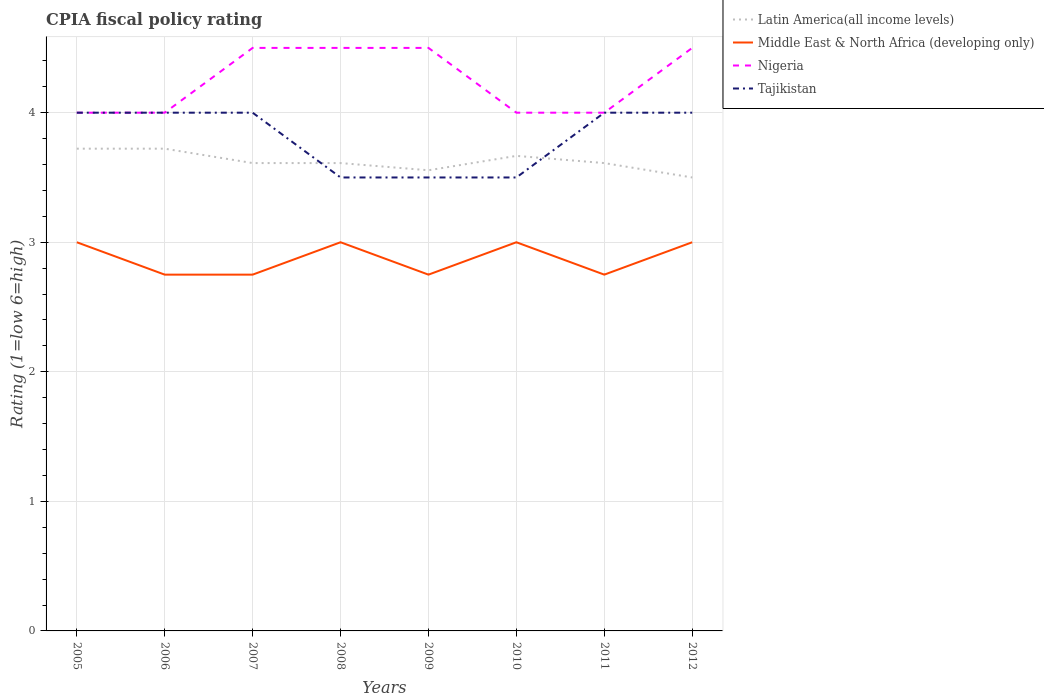Is the number of lines equal to the number of legend labels?
Offer a very short reply. Yes. Across all years, what is the maximum CPIA rating in Nigeria?
Your answer should be compact. 4. What is the difference between the highest and the lowest CPIA rating in Nigeria?
Provide a short and direct response. 4. How many lines are there?
Ensure brevity in your answer.  4. How many years are there in the graph?
Offer a very short reply. 8. What is the difference between two consecutive major ticks on the Y-axis?
Make the answer very short. 1. Are the values on the major ticks of Y-axis written in scientific E-notation?
Your answer should be compact. No. Does the graph contain grids?
Provide a succinct answer. Yes. Where does the legend appear in the graph?
Offer a terse response. Top right. How are the legend labels stacked?
Your answer should be very brief. Vertical. What is the title of the graph?
Give a very brief answer. CPIA fiscal policy rating. What is the label or title of the Y-axis?
Give a very brief answer. Rating (1=low 6=high). What is the Rating (1=low 6=high) in Latin America(all income levels) in 2005?
Your answer should be very brief. 3.72. What is the Rating (1=low 6=high) of Tajikistan in 2005?
Your response must be concise. 4. What is the Rating (1=low 6=high) in Latin America(all income levels) in 2006?
Ensure brevity in your answer.  3.72. What is the Rating (1=low 6=high) in Middle East & North Africa (developing only) in 2006?
Ensure brevity in your answer.  2.75. What is the Rating (1=low 6=high) of Latin America(all income levels) in 2007?
Give a very brief answer. 3.61. What is the Rating (1=low 6=high) in Middle East & North Africa (developing only) in 2007?
Your answer should be compact. 2.75. What is the Rating (1=low 6=high) of Tajikistan in 2007?
Ensure brevity in your answer.  4. What is the Rating (1=low 6=high) in Latin America(all income levels) in 2008?
Offer a terse response. 3.61. What is the Rating (1=low 6=high) in Middle East & North Africa (developing only) in 2008?
Make the answer very short. 3. What is the Rating (1=low 6=high) of Nigeria in 2008?
Ensure brevity in your answer.  4.5. What is the Rating (1=low 6=high) of Latin America(all income levels) in 2009?
Make the answer very short. 3.56. What is the Rating (1=low 6=high) of Middle East & North Africa (developing only) in 2009?
Give a very brief answer. 2.75. What is the Rating (1=low 6=high) in Nigeria in 2009?
Your answer should be very brief. 4.5. What is the Rating (1=low 6=high) in Tajikistan in 2009?
Offer a terse response. 3.5. What is the Rating (1=low 6=high) in Latin America(all income levels) in 2010?
Provide a short and direct response. 3.67. What is the Rating (1=low 6=high) of Tajikistan in 2010?
Offer a terse response. 3.5. What is the Rating (1=low 6=high) in Latin America(all income levels) in 2011?
Your response must be concise. 3.61. What is the Rating (1=low 6=high) of Middle East & North Africa (developing only) in 2011?
Give a very brief answer. 2.75. What is the Rating (1=low 6=high) of Nigeria in 2011?
Provide a succinct answer. 4. What is the Rating (1=low 6=high) of Latin America(all income levels) in 2012?
Give a very brief answer. 3.5. What is the Rating (1=low 6=high) of Nigeria in 2012?
Your answer should be compact. 4.5. Across all years, what is the maximum Rating (1=low 6=high) in Latin America(all income levels)?
Provide a succinct answer. 3.72. Across all years, what is the maximum Rating (1=low 6=high) of Middle East & North Africa (developing only)?
Ensure brevity in your answer.  3. Across all years, what is the maximum Rating (1=low 6=high) of Nigeria?
Your answer should be very brief. 4.5. Across all years, what is the minimum Rating (1=low 6=high) in Middle East & North Africa (developing only)?
Offer a terse response. 2.75. Across all years, what is the minimum Rating (1=low 6=high) in Nigeria?
Offer a very short reply. 4. Across all years, what is the minimum Rating (1=low 6=high) in Tajikistan?
Offer a very short reply. 3.5. What is the total Rating (1=low 6=high) in Middle East & North Africa (developing only) in the graph?
Provide a short and direct response. 23. What is the total Rating (1=low 6=high) in Tajikistan in the graph?
Ensure brevity in your answer.  30.5. What is the difference between the Rating (1=low 6=high) of Middle East & North Africa (developing only) in 2005 and that in 2006?
Your answer should be very brief. 0.25. What is the difference between the Rating (1=low 6=high) in Nigeria in 2005 and that in 2006?
Offer a terse response. 0. What is the difference between the Rating (1=low 6=high) of Middle East & North Africa (developing only) in 2005 and that in 2007?
Offer a terse response. 0.25. What is the difference between the Rating (1=low 6=high) in Nigeria in 2005 and that in 2007?
Your response must be concise. -0.5. What is the difference between the Rating (1=low 6=high) of Latin America(all income levels) in 2005 and that in 2008?
Give a very brief answer. 0.11. What is the difference between the Rating (1=low 6=high) of Middle East & North Africa (developing only) in 2005 and that in 2008?
Provide a short and direct response. 0. What is the difference between the Rating (1=low 6=high) in Nigeria in 2005 and that in 2008?
Ensure brevity in your answer.  -0.5. What is the difference between the Rating (1=low 6=high) in Middle East & North Africa (developing only) in 2005 and that in 2009?
Keep it short and to the point. 0.25. What is the difference between the Rating (1=low 6=high) in Nigeria in 2005 and that in 2009?
Your response must be concise. -0.5. What is the difference between the Rating (1=low 6=high) in Latin America(all income levels) in 2005 and that in 2010?
Offer a very short reply. 0.06. What is the difference between the Rating (1=low 6=high) of Middle East & North Africa (developing only) in 2005 and that in 2010?
Your answer should be compact. 0. What is the difference between the Rating (1=low 6=high) in Tajikistan in 2005 and that in 2010?
Ensure brevity in your answer.  0.5. What is the difference between the Rating (1=low 6=high) in Middle East & North Africa (developing only) in 2005 and that in 2011?
Keep it short and to the point. 0.25. What is the difference between the Rating (1=low 6=high) in Nigeria in 2005 and that in 2011?
Provide a succinct answer. 0. What is the difference between the Rating (1=low 6=high) in Latin America(all income levels) in 2005 and that in 2012?
Offer a terse response. 0.22. What is the difference between the Rating (1=low 6=high) in Middle East & North Africa (developing only) in 2005 and that in 2012?
Give a very brief answer. 0. What is the difference between the Rating (1=low 6=high) in Tajikistan in 2005 and that in 2012?
Offer a very short reply. 0. What is the difference between the Rating (1=low 6=high) of Middle East & North Africa (developing only) in 2006 and that in 2007?
Offer a very short reply. 0. What is the difference between the Rating (1=low 6=high) in Nigeria in 2006 and that in 2007?
Ensure brevity in your answer.  -0.5. What is the difference between the Rating (1=low 6=high) in Latin America(all income levels) in 2006 and that in 2008?
Your answer should be very brief. 0.11. What is the difference between the Rating (1=low 6=high) in Latin America(all income levels) in 2006 and that in 2010?
Your response must be concise. 0.06. What is the difference between the Rating (1=low 6=high) in Tajikistan in 2006 and that in 2010?
Your answer should be compact. 0.5. What is the difference between the Rating (1=low 6=high) in Middle East & North Africa (developing only) in 2006 and that in 2011?
Provide a succinct answer. 0. What is the difference between the Rating (1=low 6=high) of Nigeria in 2006 and that in 2011?
Make the answer very short. 0. What is the difference between the Rating (1=low 6=high) of Latin America(all income levels) in 2006 and that in 2012?
Your response must be concise. 0.22. What is the difference between the Rating (1=low 6=high) of Nigeria in 2006 and that in 2012?
Your answer should be compact. -0.5. What is the difference between the Rating (1=low 6=high) of Middle East & North Africa (developing only) in 2007 and that in 2008?
Ensure brevity in your answer.  -0.25. What is the difference between the Rating (1=low 6=high) in Tajikistan in 2007 and that in 2008?
Your answer should be compact. 0.5. What is the difference between the Rating (1=low 6=high) of Latin America(all income levels) in 2007 and that in 2009?
Your response must be concise. 0.06. What is the difference between the Rating (1=low 6=high) in Middle East & North Africa (developing only) in 2007 and that in 2009?
Your answer should be compact. 0. What is the difference between the Rating (1=low 6=high) of Tajikistan in 2007 and that in 2009?
Your response must be concise. 0.5. What is the difference between the Rating (1=low 6=high) in Latin America(all income levels) in 2007 and that in 2010?
Offer a terse response. -0.06. What is the difference between the Rating (1=low 6=high) of Tajikistan in 2007 and that in 2010?
Make the answer very short. 0.5. What is the difference between the Rating (1=low 6=high) of Latin America(all income levels) in 2007 and that in 2011?
Ensure brevity in your answer.  0. What is the difference between the Rating (1=low 6=high) of Middle East & North Africa (developing only) in 2007 and that in 2011?
Your answer should be very brief. 0. What is the difference between the Rating (1=low 6=high) of Nigeria in 2007 and that in 2011?
Provide a succinct answer. 0.5. What is the difference between the Rating (1=low 6=high) in Tajikistan in 2007 and that in 2011?
Give a very brief answer. 0. What is the difference between the Rating (1=low 6=high) in Latin America(all income levels) in 2007 and that in 2012?
Ensure brevity in your answer.  0.11. What is the difference between the Rating (1=low 6=high) of Middle East & North Africa (developing only) in 2007 and that in 2012?
Make the answer very short. -0.25. What is the difference between the Rating (1=low 6=high) in Latin America(all income levels) in 2008 and that in 2009?
Make the answer very short. 0.06. What is the difference between the Rating (1=low 6=high) of Latin America(all income levels) in 2008 and that in 2010?
Your response must be concise. -0.06. What is the difference between the Rating (1=low 6=high) of Middle East & North Africa (developing only) in 2008 and that in 2010?
Keep it short and to the point. 0. What is the difference between the Rating (1=low 6=high) in Tajikistan in 2008 and that in 2010?
Keep it short and to the point. 0. What is the difference between the Rating (1=low 6=high) of Latin America(all income levels) in 2008 and that in 2011?
Your answer should be compact. 0. What is the difference between the Rating (1=low 6=high) in Latin America(all income levels) in 2008 and that in 2012?
Your response must be concise. 0.11. What is the difference between the Rating (1=low 6=high) in Nigeria in 2008 and that in 2012?
Offer a very short reply. 0. What is the difference between the Rating (1=low 6=high) of Latin America(all income levels) in 2009 and that in 2010?
Your response must be concise. -0.11. What is the difference between the Rating (1=low 6=high) of Nigeria in 2009 and that in 2010?
Offer a terse response. 0.5. What is the difference between the Rating (1=low 6=high) of Tajikistan in 2009 and that in 2010?
Your answer should be compact. 0. What is the difference between the Rating (1=low 6=high) of Latin America(all income levels) in 2009 and that in 2011?
Your answer should be very brief. -0.06. What is the difference between the Rating (1=low 6=high) of Middle East & North Africa (developing only) in 2009 and that in 2011?
Make the answer very short. 0. What is the difference between the Rating (1=low 6=high) of Tajikistan in 2009 and that in 2011?
Ensure brevity in your answer.  -0.5. What is the difference between the Rating (1=low 6=high) of Latin America(all income levels) in 2009 and that in 2012?
Keep it short and to the point. 0.06. What is the difference between the Rating (1=low 6=high) of Middle East & North Africa (developing only) in 2009 and that in 2012?
Your answer should be very brief. -0.25. What is the difference between the Rating (1=low 6=high) of Latin America(all income levels) in 2010 and that in 2011?
Make the answer very short. 0.06. What is the difference between the Rating (1=low 6=high) of Nigeria in 2010 and that in 2011?
Make the answer very short. 0. What is the difference between the Rating (1=low 6=high) of Tajikistan in 2010 and that in 2011?
Give a very brief answer. -0.5. What is the difference between the Rating (1=low 6=high) in Middle East & North Africa (developing only) in 2011 and that in 2012?
Provide a short and direct response. -0.25. What is the difference between the Rating (1=low 6=high) of Tajikistan in 2011 and that in 2012?
Offer a very short reply. 0. What is the difference between the Rating (1=low 6=high) of Latin America(all income levels) in 2005 and the Rating (1=low 6=high) of Middle East & North Africa (developing only) in 2006?
Make the answer very short. 0.97. What is the difference between the Rating (1=low 6=high) of Latin America(all income levels) in 2005 and the Rating (1=low 6=high) of Nigeria in 2006?
Keep it short and to the point. -0.28. What is the difference between the Rating (1=low 6=high) of Latin America(all income levels) in 2005 and the Rating (1=low 6=high) of Tajikistan in 2006?
Your response must be concise. -0.28. What is the difference between the Rating (1=low 6=high) of Middle East & North Africa (developing only) in 2005 and the Rating (1=low 6=high) of Nigeria in 2006?
Give a very brief answer. -1. What is the difference between the Rating (1=low 6=high) of Latin America(all income levels) in 2005 and the Rating (1=low 6=high) of Middle East & North Africa (developing only) in 2007?
Offer a very short reply. 0.97. What is the difference between the Rating (1=low 6=high) in Latin America(all income levels) in 2005 and the Rating (1=low 6=high) in Nigeria in 2007?
Your answer should be compact. -0.78. What is the difference between the Rating (1=low 6=high) of Latin America(all income levels) in 2005 and the Rating (1=low 6=high) of Tajikistan in 2007?
Your response must be concise. -0.28. What is the difference between the Rating (1=low 6=high) of Middle East & North Africa (developing only) in 2005 and the Rating (1=low 6=high) of Nigeria in 2007?
Offer a terse response. -1.5. What is the difference between the Rating (1=low 6=high) in Nigeria in 2005 and the Rating (1=low 6=high) in Tajikistan in 2007?
Offer a terse response. 0. What is the difference between the Rating (1=low 6=high) of Latin America(all income levels) in 2005 and the Rating (1=low 6=high) of Middle East & North Africa (developing only) in 2008?
Make the answer very short. 0.72. What is the difference between the Rating (1=low 6=high) in Latin America(all income levels) in 2005 and the Rating (1=low 6=high) in Nigeria in 2008?
Provide a succinct answer. -0.78. What is the difference between the Rating (1=low 6=high) of Latin America(all income levels) in 2005 and the Rating (1=low 6=high) of Tajikistan in 2008?
Provide a short and direct response. 0.22. What is the difference between the Rating (1=low 6=high) in Middle East & North Africa (developing only) in 2005 and the Rating (1=low 6=high) in Nigeria in 2008?
Your answer should be very brief. -1.5. What is the difference between the Rating (1=low 6=high) in Nigeria in 2005 and the Rating (1=low 6=high) in Tajikistan in 2008?
Your answer should be very brief. 0.5. What is the difference between the Rating (1=low 6=high) of Latin America(all income levels) in 2005 and the Rating (1=low 6=high) of Middle East & North Africa (developing only) in 2009?
Give a very brief answer. 0.97. What is the difference between the Rating (1=low 6=high) of Latin America(all income levels) in 2005 and the Rating (1=low 6=high) of Nigeria in 2009?
Keep it short and to the point. -0.78. What is the difference between the Rating (1=low 6=high) in Latin America(all income levels) in 2005 and the Rating (1=low 6=high) in Tajikistan in 2009?
Your response must be concise. 0.22. What is the difference between the Rating (1=low 6=high) of Middle East & North Africa (developing only) in 2005 and the Rating (1=low 6=high) of Nigeria in 2009?
Give a very brief answer. -1.5. What is the difference between the Rating (1=low 6=high) in Nigeria in 2005 and the Rating (1=low 6=high) in Tajikistan in 2009?
Ensure brevity in your answer.  0.5. What is the difference between the Rating (1=low 6=high) in Latin America(all income levels) in 2005 and the Rating (1=low 6=high) in Middle East & North Africa (developing only) in 2010?
Give a very brief answer. 0.72. What is the difference between the Rating (1=low 6=high) of Latin America(all income levels) in 2005 and the Rating (1=low 6=high) of Nigeria in 2010?
Keep it short and to the point. -0.28. What is the difference between the Rating (1=low 6=high) in Latin America(all income levels) in 2005 and the Rating (1=low 6=high) in Tajikistan in 2010?
Provide a short and direct response. 0.22. What is the difference between the Rating (1=low 6=high) in Nigeria in 2005 and the Rating (1=low 6=high) in Tajikistan in 2010?
Make the answer very short. 0.5. What is the difference between the Rating (1=low 6=high) in Latin America(all income levels) in 2005 and the Rating (1=low 6=high) in Middle East & North Africa (developing only) in 2011?
Your answer should be very brief. 0.97. What is the difference between the Rating (1=low 6=high) of Latin America(all income levels) in 2005 and the Rating (1=low 6=high) of Nigeria in 2011?
Offer a very short reply. -0.28. What is the difference between the Rating (1=low 6=high) of Latin America(all income levels) in 2005 and the Rating (1=low 6=high) of Tajikistan in 2011?
Make the answer very short. -0.28. What is the difference between the Rating (1=low 6=high) in Middle East & North Africa (developing only) in 2005 and the Rating (1=low 6=high) in Tajikistan in 2011?
Offer a very short reply. -1. What is the difference between the Rating (1=low 6=high) of Latin America(all income levels) in 2005 and the Rating (1=low 6=high) of Middle East & North Africa (developing only) in 2012?
Provide a short and direct response. 0.72. What is the difference between the Rating (1=low 6=high) in Latin America(all income levels) in 2005 and the Rating (1=low 6=high) in Nigeria in 2012?
Provide a succinct answer. -0.78. What is the difference between the Rating (1=low 6=high) in Latin America(all income levels) in 2005 and the Rating (1=low 6=high) in Tajikistan in 2012?
Provide a succinct answer. -0.28. What is the difference between the Rating (1=low 6=high) in Middle East & North Africa (developing only) in 2005 and the Rating (1=low 6=high) in Tajikistan in 2012?
Offer a very short reply. -1. What is the difference between the Rating (1=low 6=high) in Latin America(all income levels) in 2006 and the Rating (1=low 6=high) in Middle East & North Africa (developing only) in 2007?
Provide a short and direct response. 0.97. What is the difference between the Rating (1=low 6=high) in Latin America(all income levels) in 2006 and the Rating (1=low 6=high) in Nigeria in 2007?
Make the answer very short. -0.78. What is the difference between the Rating (1=low 6=high) of Latin America(all income levels) in 2006 and the Rating (1=low 6=high) of Tajikistan in 2007?
Provide a succinct answer. -0.28. What is the difference between the Rating (1=low 6=high) of Middle East & North Africa (developing only) in 2006 and the Rating (1=low 6=high) of Nigeria in 2007?
Make the answer very short. -1.75. What is the difference between the Rating (1=low 6=high) in Middle East & North Africa (developing only) in 2006 and the Rating (1=low 6=high) in Tajikistan in 2007?
Keep it short and to the point. -1.25. What is the difference between the Rating (1=low 6=high) of Nigeria in 2006 and the Rating (1=low 6=high) of Tajikistan in 2007?
Your answer should be very brief. 0. What is the difference between the Rating (1=low 6=high) of Latin America(all income levels) in 2006 and the Rating (1=low 6=high) of Middle East & North Africa (developing only) in 2008?
Keep it short and to the point. 0.72. What is the difference between the Rating (1=low 6=high) of Latin America(all income levels) in 2006 and the Rating (1=low 6=high) of Nigeria in 2008?
Make the answer very short. -0.78. What is the difference between the Rating (1=low 6=high) of Latin America(all income levels) in 2006 and the Rating (1=low 6=high) of Tajikistan in 2008?
Your answer should be very brief. 0.22. What is the difference between the Rating (1=low 6=high) in Middle East & North Africa (developing only) in 2006 and the Rating (1=low 6=high) in Nigeria in 2008?
Provide a short and direct response. -1.75. What is the difference between the Rating (1=low 6=high) in Middle East & North Africa (developing only) in 2006 and the Rating (1=low 6=high) in Tajikistan in 2008?
Provide a short and direct response. -0.75. What is the difference between the Rating (1=low 6=high) of Nigeria in 2006 and the Rating (1=low 6=high) of Tajikistan in 2008?
Ensure brevity in your answer.  0.5. What is the difference between the Rating (1=low 6=high) in Latin America(all income levels) in 2006 and the Rating (1=low 6=high) in Middle East & North Africa (developing only) in 2009?
Provide a succinct answer. 0.97. What is the difference between the Rating (1=low 6=high) in Latin America(all income levels) in 2006 and the Rating (1=low 6=high) in Nigeria in 2009?
Your answer should be compact. -0.78. What is the difference between the Rating (1=low 6=high) of Latin America(all income levels) in 2006 and the Rating (1=low 6=high) of Tajikistan in 2009?
Offer a terse response. 0.22. What is the difference between the Rating (1=low 6=high) in Middle East & North Africa (developing only) in 2006 and the Rating (1=low 6=high) in Nigeria in 2009?
Provide a short and direct response. -1.75. What is the difference between the Rating (1=low 6=high) of Middle East & North Africa (developing only) in 2006 and the Rating (1=low 6=high) of Tajikistan in 2009?
Provide a succinct answer. -0.75. What is the difference between the Rating (1=low 6=high) in Nigeria in 2006 and the Rating (1=low 6=high) in Tajikistan in 2009?
Give a very brief answer. 0.5. What is the difference between the Rating (1=low 6=high) of Latin America(all income levels) in 2006 and the Rating (1=low 6=high) of Middle East & North Africa (developing only) in 2010?
Ensure brevity in your answer.  0.72. What is the difference between the Rating (1=low 6=high) in Latin America(all income levels) in 2006 and the Rating (1=low 6=high) in Nigeria in 2010?
Your answer should be very brief. -0.28. What is the difference between the Rating (1=low 6=high) in Latin America(all income levels) in 2006 and the Rating (1=low 6=high) in Tajikistan in 2010?
Give a very brief answer. 0.22. What is the difference between the Rating (1=low 6=high) of Middle East & North Africa (developing only) in 2006 and the Rating (1=low 6=high) of Nigeria in 2010?
Provide a succinct answer. -1.25. What is the difference between the Rating (1=low 6=high) of Middle East & North Africa (developing only) in 2006 and the Rating (1=low 6=high) of Tajikistan in 2010?
Your answer should be compact. -0.75. What is the difference between the Rating (1=low 6=high) of Latin America(all income levels) in 2006 and the Rating (1=low 6=high) of Middle East & North Africa (developing only) in 2011?
Provide a short and direct response. 0.97. What is the difference between the Rating (1=low 6=high) of Latin America(all income levels) in 2006 and the Rating (1=low 6=high) of Nigeria in 2011?
Ensure brevity in your answer.  -0.28. What is the difference between the Rating (1=low 6=high) in Latin America(all income levels) in 2006 and the Rating (1=low 6=high) in Tajikistan in 2011?
Give a very brief answer. -0.28. What is the difference between the Rating (1=low 6=high) in Middle East & North Africa (developing only) in 2006 and the Rating (1=low 6=high) in Nigeria in 2011?
Provide a succinct answer. -1.25. What is the difference between the Rating (1=low 6=high) of Middle East & North Africa (developing only) in 2006 and the Rating (1=low 6=high) of Tajikistan in 2011?
Ensure brevity in your answer.  -1.25. What is the difference between the Rating (1=low 6=high) in Latin America(all income levels) in 2006 and the Rating (1=low 6=high) in Middle East & North Africa (developing only) in 2012?
Your response must be concise. 0.72. What is the difference between the Rating (1=low 6=high) of Latin America(all income levels) in 2006 and the Rating (1=low 6=high) of Nigeria in 2012?
Offer a terse response. -0.78. What is the difference between the Rating (1=low 6=high) in Latin America(all income levels) in 2006 and the Rating (1=low 6=high) in Tajikistan in 2012?
Provide a short and direct response. -0.28. What is the difference between the Rating (1=low 6=high) in Middle East & North Africa (developing only) in 2006 and the Rating (1=low 6=high) in Nigeria in 2012?
Your answer should be very brief. -1.75. What is the difference between the Rating (1=low 6=high) of Middle East & North Africa (developing only) in 2006 and the Rating (1=low 6=high) of Tajikistan in 2012?
Provide a short and direct response. -1.25. What is the difference between the Rating (1=low 6=high) of Nigeria in 2006 and the Rating (1=low 6=high) of Tajikistan in 2012?
Your answer should be very brief. 0. What is the difference between the Rating (1=low 6=high) of Latin America(all income levels) in 2007 and the Rating (1=low 6=high) of Middle East & North Africa (developing only) in 2008?
Provide a succinct answer. 0.61. What is the difference between the Rating (1=low 6=high) of Latin America(all income levels) in 2007 and the Rating (1=low 6=high) of Nigeria in 2008?
Your response must be concise. -0.89. What is the difference between the Rating (1=low 6=high) of Latin America(all income levels) in 2007 and the Rating (1=low 6=high) of Tajikistan in 2008?
Your answer should be very brief. 0.11. What is the difference between the Rating (1=low 6=high) of Middle East & North Africa (developing only) in 2007 and the Rating (1=low 6=high) of Nigeria in 2008?
Keep it short and to the point. -1.75. What is the difference between the Rating (1=low 6=high) of Middle East & North Africa (developing only) in 2007 and the Rating (1=low 6=high) of Tajikistan in 2008?
Your response must be concise. -0.75. What is the difference between the Rating (1=low 6=high) of Nigeria in 2007 and the Rating (1=low 6=high) of Tajikistan in 2008?
Ensure brevity in your answer.  1. What is the difference between the Rating (1=low 6=high) in Latin America(all income levels) in 2007 and the Rating (1=low 6=high) in Middle East & North Africa (developing only) in 2009?
Offer a very short reply. 0.86. What is the difference between the Rating (1=low 6=high) in Latin America(all income levels) in 2007 and the Rating (1=low 6=high) in Nigeria in 2009?
Provide a short and direct response. -0.89. What is the difference between the Rating (1=low 6=high) of Latin America(all income levels) in 2007 and the Rating (1=low 6=high) of Tajikistan in 2009?
Give a very brief answer. 0.11. What is the difference between the Rating (1=low 6=high) of Middle East & North Africa (developing only) in 2007 and the Rating (1=low 6=high) of Nigeria in 2009?
Your response must be concise. -1.75. What is the difference between the Rating (1=low 6=high) of Middle East & North Africa (developing only) in 2007 and the Rating (1=low 6=high) of Tajikistan in 2009?
Provide a succinct answer. -0.75. What is the difference between the Rating (1=low 6=high) of Latin America(all income levels) in 2007 and the Rating (1=low 6=high) of Middle East & North Africa (developing only) in 2010?
Your answer should be compact. 0.61. What is the difference between the Rating (1=low 6=high) in Latin America(all income levels) in 2007 and the Rating (1=low 6=high) in Nigeria in 2010?
Make the answer very short. -0.39. What is the difference between the Rating (1=low 6=high) in Latin America(all income levels) in 2007 and the Rating (1=low 6=high) in Tajikistan in 2010?
Offer a very short reply. 0.11. What is the difference between the Rating (1=low 6=high) in Middle East & North Africa (developing only) in 2007 and the Rating (1=low 6=high) in Nigeria in 2010?
Keep it short and to the point. -1.25. What is the difference between the Rating (1=low 6=high) of Middle East & North Africa (developing only) in 2007 and the Rating (1=low 6=high) of Tajikistan in 2010?
Your answer should be compact. -0.75. What is the difference between the Rating (1=low 6=high) in Nigeria in 2007 and the Rating (1=low 6=high) in Tajikistan in 2010?
Give a very brief answer. 1. What is the difference between the Rating (1=low 6=high) of Latin America(all income levels) in 2007 and the Rating (1=low 6=high) of Middle East & North Africa (developing only) in 2011?
Your response must be concise. 0.86. What is the difference between the Rating (1=low 6=high) in Latin America(all income levels) in 2007 and the Rating (1=low 6=high) in Nigeria in 2011?
Make the answer very short. -0.39. What is the difference between the Rating (1=low 6=high) of Latin America(all income levels) in 2007 and the Rating (1=low 6=high) of Tajikistan in 2011?
Your answer should be very brief. -0.39. What is the difference between the Rating (1=low 6=high) of Middle East & North Africa (developing only) in 2007 and the Rating (1=low 6=high) of Nigeria in 2011?
Offer a very short reply. -1.25. What is the difference between the Rating (1=low 6=high) in Middle East & North Africa (developing only) in 2007 and the Rating (1=low 6=high) in Tajikistan in 2011?
Your response must be concise. -1.25. What is the difference between the Rating (1=low 6=high) in Nigeria in 2007 and the Rating (1=low 6=high) in Tajikistan in 2011?
Offer a terse response. 0.5. What is the difference between the Rating (1=low 6=high) of Latin America(all income levels) in 2007 and the Rating (1=low 6=high) of Middle East & North Africa (developing only) in 2012?
Offer a terse response. 0.61. What is the difference between the Rating (1=low 6=high) in Latin America(all income levels) in 2007 and the Rating (1=low 6=high) in Nigeria in 2012?
Provide a succinct answer. -0.89. What is the difference between the Rating (1=low 6=high) of Latin America(all income levels) in 2007 and the Rating (1=low 6=high) of Tajikistan in 2012?
Provide a succinct answer. -0.39. What is the difference between the Rating (1=low 6=high) of Middle East & North Africa (developing only) in 2007 and the Rating (1=low 6=high) of Nigeria in 2012?
Your answer should be compact. -1.75. What is the difference between the Rating (1=low 6=high) in Middle East & North Africa (developing only) in 2007 and the Rating (1=low 6=high) in Tajikistan in 2012?
Provide a short and direct response. -1.25. What is the difference between the Rating (1=low 6=high) of Nigeria in 2007 and the Rating (1=low 6=high) of Tajikistan in 2012?
Make the answer very short. 0.5. What is the difference between the Rating (1=low 6=high) of Latin America(all income levels) in 2008 and the Rating (1=low 6=high) of Middle East & North Africa (developing only) in 2009?
Give a very brief answer. 0.86. What is the difference between the Rating (1=low 6=high) in Latin America(all income levels) in 2008 and the Rating (1=low 6=high) in Nigeria in 2009?
Your response must be concise. -0.89. What is the difference between the Rating (1=low 6=high) in Latin America(all income levels) in 2008 and the Rating (1=low 6=high) in Middle East & North Africa (developing only) in 2010?
Your answer should be very brief. 0.61. What is the difference between the Rating (1=low 6=high) in Latin America(all income levels) in 2008 and the Rating (1=low 6=high) in Nigeria in 2010?
Your answer should be very brief. -0.39. What is the difference between the Rating (1=low 6=high) in Middle East & North Africa (developing only) in 2008 and the Rating (1=low 6=high) in Nigeria in 2010?
Keep it short and to the point. -1. What is the difference between the Rating (1=low 6=high) in Nigeria in 2008 and the Rating (1=low 6=high) in Tajikistan in 2010?
Provide a short and direct response. 1. What is the difference between the Rating (1=low 6=high) in Latin America(all income levels) in 2008 and the Rating (1=low 6=high) in Middle East & North Africa (developing only) in 2011?
Ensure brevity in your answer.  0.86. What is the difference between the Rating (1=low 6=high) in Latin America(all income levels) in 2008 and the Rating (1=low 6=high) in Nigeria in 2011?
Provide a succinct answer. -0.39. What is the difference between the Rating (1=low 6=high) of Latin America(all income levels) in 2008 and the Rating (1=low 6=high) of Tajikistan in 2011?
Make the answer very short. -0.39. What is the difference between the Rating (1=low 6=high) in Middle East & North Africa (developing only) in 2008 and the Rating (1=low 6=high) in Nigeria in 2011?
Provide a succinct answer. -1. What is the difference between the Rating (1=low 6=high) of Middle East & North Africa (developing only) in 2008 and the Rating (1=low 6=high) of Tajikistan in 2011?
Offer a terse response. -1. What is the difference between the Rating (1=low 6=high) in Latin America(all income levels) in 2008 and the Rating (1=low 6=high) in Middle East & North Africa (developing only) in 2012?
Offer a very short reply. 0.61. What is the difference between the Rating (1=low 6=high) in Latin America(all income levels) in 2008 and the Rating (1=low 6=high) in Nigeria in 2012?
Give a very brief answer. -0.89. What is the difference between the Rating (1=low 6=high) of Latin America(all income levels) in 2008 and the Rating (1=low 6=high) of Tajikistan in 2012?
Your response must be concise. -0.39. What is the difference between the Rating (1=low 6=high) in Middle East & North Africa (developing only) in 2008 and the Rating (1=low 6=high) in Tajikistan in 2012?
Offer a very short reply. -1. What is the difference between the Rating (1=low 6=high) of Latin America(all income levels) in 2009 and the Rating (1=low 6=high) of Middle East & North Africa (developing only) in 2010?
Provide a short and direct response. 0.56. What is the difference between the Rating (1=low 6=high) in Latin America(all income levels) in 2009 and the Rating (1=low 6=high) in Nigeria in 2010?
Ensure brevity in your answer.  -0.44. What is the difference between the Rating (1=low 6=high) in Latin America(all income levels) in 2009 and the Rating (1=low 6=high) in Tajikistan in 2010?
Your answer should be compact. 0.06. What is the difference between the Rating (1=low 6=high) in Middle East & North Africa (developing only) in 2009 and the Rating (1=low 6=high) in Nigeria in 2010?
Your answer should be very brief. -1.25. What is the difference between the Rating (1=low 6=high) in Middle East & North Africa (developing only) in 2009 and the Rating (1=low 6=high) in Tajikistan in 2010?
Your answer should be very brief. -0.75. What is the difference between the Rating (1=low 6=high) in Latin America(all income levels) in 2009 and the Rating (1=low 6=high) in Middle East & North Africa (developing only) in 2011?
Keep it short and to the point. 0.81. What is the difference between the Rating (1=low 6=high) of Latin America(all income levels) in 2009 and the Rating (1=low 6=high) of Nigeria in 2011?
Provide a short and direct response. -0.44. What is the difference between the Rating (1=low 6=high) in Latin America(all income levels) in 2009 and the Rating (1=low 6=high) in Tajikistan in 2011?
Make the answer very short. -0.44. What is the difference between the Rating (1=low 6=high) in Middle East & North Africa (developing only) in 2009 and the Rating (1=low 6=high) in Nigeria in 2011?
Your response must be concise. -1.25. What is the difference between the Rating (1=low 6=high) in Middle East & North Africa (developing only) in 2009 and the Rating (1=low 6=high) in Tajikistan in 2011?
Your answer should be very brief. -1.25. What is the difference between the Rating (1=low 6=high) of Nigeria in 2009 and the Rating (1=low 6=high) of Tajikistan in 2011?
Keep it short and to the point. 0.5. What is the difference between the Rating (1=low 6=high) in Latin America(all income levels) in 2009 and the Rating (1=low 6=high) in Middle East & North Africa (developing only) in 2012?
Provide a succinct answer. 0.56. What is the difference between the Rating (1=low 6=high) in Latin America(all income levels) in 2009 and the Rating (1=low 6=high) in Nigeria in 2012?
Offer a terse response. -0.94. What is the difference between the Rating (1=low 6=high) in Latin America(all income levels) in 2009 and the Rating (1=low 6=high) in Tajikistan in 2012?
Offer a terse response. -0.44. What is the difference between the Rating (1=low 6=high) in Middle East & North Africa (developing only) in 2009 and the Rating (1=low 6=high) in Nigeria in 2012?
Offer a very short reply. -1.75. What is the difference between the Rating (1=low 6=high) in Middle East & North Africa (developing only) in 2009 and the Rating (1=low 6=high) in Tajikistan in 2012?
Ensure brevity in your answer.  -1.25. What is the difference between the Rating (1=low 6=high) of Nigeria in 2009 and the Rating (1=low 6=high) of Tajikistan in 2012?
Provide a succinct answer. 0.5. What is the difference between the Rating (1=low 6=high) in Latin America(all income levels) in 2010 and the Rating (1=low 6=high) in Nigeria in 2011?
Ensure brevity in your answer.  -0.33. What is the difference between the Rating (1=low 6=high) in Nigeria in 2010 and the Rating (1=low 6=high) in Tajikistan in 2011?
Ensure brevity in your answer.  0. What is the difference between the Rating (1=low 6=high) in Latin America(all income levels) in 2010 and the Rating (1=low 6=high) in Middle East & North Africa (developing only) in 2012?
Ensure brevity in your answer.  0.67. What is the difference between the Rating (1=low 6=high) of Middle East & North Africa (developing only) in 2010 and the Rating (1=low 6=high) of Tajikistan in 2012?
Give a very brief answer. -1. What is the difference between the Rating (1=low 6=high) of Latin America(all income levels) in 2011 and the Rating (1=low 6=high) of Middle East & North Africa (developing only) in 2012?
Offer a very short reply. 0.61. What is the difference between the Rating (1=low 6=high) in Latin America(all income levels) in 2011 and the Rating (1=low 6=high) in Nigeria in 2012?
Ensure brevity in your answer.  -0.89. What is the difference between the Rating (1=low 6=high) of Latin America(all income levels) in 2011 and the Rating (1=low 6=high) of Tajikistan in 2012?
Offer a very short reply. -0.39. What is the difference between the Rating (1=low 6=high) in Middle East & North Africa (developing only) in 2011 and the Rating (1=low 6=high) in Nigeria in 2012?
Give a very brief answer. -1.75. What is the difference between the Rating (1=low 6=high) of Middle East & North Africa (developing only) in 2011 and the Rating (1=low 6=high) of Tajikistan in 2012?
Keep it short and to the point. -1.25. What is the average Rating (1=low 6=high) of Latin America(all income levels) per year?
Make the answer very short. 3.62. What is the average Rating (1=low 6=high) in Middle East & North Africa (developing only) per year?
Make the answer very short. 2.88. What is the average Rating (1=low 6=high) in Nigeria per year?
Provide a succinct answer. 4.25. What is the average Rating (1=low 6=high) of Tajikistan per year?
Provide a short and direct response. 3.81. In the year 2005, what is the difference between the Rating (1=low 6=high) in Latin America(all income levels) and Rating (1=low 6=high) in Middle East & North Africa (developing only)?
Keep it short and to the point. 0.72. In the year 2005, what is the difference between the Rating (1=low 6=high) in Latin America(all income levels) and Rating (1=low 6=high) in Nigeria?
Make the answer very short. -0.28. In the year 2005, what is the difference between the Rating (1=low 6=high) of Latin America(all income levels) and Rating (1=low 6=high) of Tajikistan?
Provide a succinct answer. -0.28. In the year 2005, what is the difference between the Rating (1=low 6=high) of Middle East & North Africa (developing only) and Rating (1=low 6=high) of Tajikistan?
Make the answer very short. -1. In the year 2005, what is the difference between the Rating (1=low 6=high) of Nigeria and Rating (1=low 6=high) of Tajikistan?
Your answer should be very brief. 0. In the year 2006, what is the difference between the Rating (1=low 6=high) in Latin America(all income levels) and Rating (1=low 6=high) in Middle East & North Africa (developing only)?
Your answer should be very brief. 0.97. In the year 2006, what is the difference between the Rating (1=low 6=high) of Latin America(all income levels) and Rating (1=low 6=high) of Nigeria?
Your response must be concise. -0.28. In the year 2006, what is the difference between the Rating (1=low 6=high) of Latin America(all income levels) and Rating (1=low 6=high) of Tajikistan?
Offer a very short reply. -0.28. In the year 2006, what is the difference between the Rating (1=low 6=high) of Middle East & North Africa (developing only) and Rating (1=low 6=high) of Nigeria?
Offer a very short reply. -1.25. In the year 2006, what is the difference between the Rating (1=low 6=high) of Middle East & North Africa (developing only) and Rating (1=low 6=high) of Tajikistan?
Make the answer very short. -1.25. In the year 2007, what is the difference between the Rating (1=low 6=high) in Latin America(all income levels) and Rating (1=low 6=high) in Middle East & North Africa (developing only)?
Your response must be concise. 0.86. In the year 2007, what is the difference between the Rating (1=low 6=high) of Latin America(all income levels) and Rating (1=low 6=high) of Nigeria?
Offer a terse response. -0.89. In the year 2007, what is the difference between the Rating (1=low 6=high) in Latin America(all income levels) and Rating (1=low 6=high) in Tajikistan?
Ensure brevity in your answer.  -0.39. In the year 2007, what is the difference between the Rating (1=low 6=high) in Middle East & North Africa (developing only) and Rating (1=low 6=high) in Nigeria?
Give a very brief answer. -1.75. In the year 2007, what is the difference between the Rating (1=low 6=high) of Middle East & North Africa (developing only) and Rating (1=low 6=high) of Tajikistan?
Give a very brief answer. -1.25. In the year 2008, what is the difference between the Rating (1=low 6=high) in Latin America(all income levels) and Rating (1=low 6=high) in Middle East & North Africa (developing only)?
Offer a very short reply. 0.61. In the year 2008, what is the difference between the Rating (1=low 6=high) in Latin America(all income levels) and Rating (1=low 6=high) in Nigeria?
Keep it short and to the point. -0.89. In the year 2008, what is the difference between the Rating (1=low 6=high) of Latin America(all income levels) and Rating (1=low 6=high) of Tajikistan?
Your answer should be very brief. 0.11. In the year 2008, what is the difference between the Rating (1=low 6=high) of Middle East & North Africa (developing only) and Rating (1=low 6=high) of Nigeria?
Make the answer very short. -1.5. In the year 2009, what is the difference between the Rating (1=low 6=high) of Latin America(all income levels) and Rating (1=low 6=high) of Middle East & North Africa (developing only)?
Your response must be concise. 0.81. In the year 2009, what is the difference between the Rating (1=low 6=high) of Latin America(all income levels) and Rating (1=low 6=high) of Nigeria?
Provide a short and direct response. -0.94. In the year 2009, what is the difference between the Rating (1=low 6=high) in Latin America(all income levels) and Rating (1=low 6=high) in Tajikistan?
Provide a succinct answer. 0.06. In the year 2009, what is the difference between the Rating (1=low 6=high) of Middle East & North Africa (developing only) and Rating (1=low 6=high) of Nigeria?
Ensure brevity in your answer.  -1.75. In the year 2009, what is the difference between the Rating (1=low 6=high) of Middle East & North Africa (developing only) and Rating (1=low 6=high) of Tajikistan?
Keep it short and to the point. -0.75. In the year 2010, what is the difference between the Rating (1=low 6=high) of Latin America(all income levels) and Rating (1=low 6=high) of Middle East & North Africa (developing only)?
Make the answer very short. 0.67. In the year 2010, what is the difference between the Rating (1=low 6=high) of Middle East & North Africa (developing only) and Rating (1=low 6=high) of Tajikistan?
Ensure brevity in your answer.  -0.5. In the year 2011, what is the difference between the Rating (1=low 6=high) of Latin America(all income levels) and Rating (1=low 6=high) of Middle East & North Africa (developing only)?
Your answer should be compact. 0.86. In the year 2011, what is the difference between the Rating (1=low 6=high) of Latin America(all income levels) and Rating (1=low 6=high) of Nigeria?
Keep it short and to the point. -0.39. In the year 2011, what is the difference between the Rating (1=low 6=high) in Latin America(all income levels) and Rating (1=low 6=high) in Tajikistan?
Your answer should be very brief. -0.39. In the year 2011, what is the difference between the Rating (1=low 6=high) in Middle East & North Africa (developing only) and Rating (1=low 6=high) in Nigeria?
Your answer should be compact. -1.25. In the year 2011, what is the difference between the Rating (1=low 6=high) of Middle East & North Africa (developing only) and Rating (1=low 6=high) of Tajikistan?
Make the answer very short. -1.25. In the year 2011, what is the difference between the Rating (1=low 6=high) of Nigeria and Rating (1=low 6=high) of Tajikistan?
Offer a terse response. 0. In the year 2012, what is the difference between the Rating (1=low 6=high) in Latin America(all income levels) and Rating (1=low 6=high) in Middle East & North Africa (developing only)?
Provide a short and direct response. 0.5. In the year 2012, what is the difference between the Rating (1=low 6=high) in Latin America(all income levels) and Rating (1=low 6=high) in Tajikistan?
Your response must be concise. -0.5. What is the ratio of the Rating (1=low 6=high) in Latin America(all income levels) in 2005 to that in 2006?
Provide a succinct answer. 1. What is the ratio of the Rating (1=low 6=high) of Middle East & North Africa (developing only) in 2005 to that in 2006?
Your answer should be very brief. 1.09. What is the ratio of the Rating (1=low 6=high) in Tajikistan in 2005 to that in 2006?
Provide a succinct answer. 1. What is the ratio of the Rating (1=low 6=high) of Latin America(all income levels) in 2005 to that in 2007?
Keep it short and to the point. 1.03. What is the ratio of the Rating (1=low 6=high) in Nigeria in 2005 to that in 2007?
Your answer should be very brief. 0.89. What is the ratio of the Rating (1=low 6=high) of Latin America(all income levels) in 2005 to that in 2008?
Offer a very short reply. 1.03. What is the ratio of the Rating (1=low 6=high) of Middle East & North Africa (developing only) in 2005 to that in 2008?
Give a very brief answer. 1. What is the ratio of the Rating (1=low 6=high) in Latin America(all income levels) in 2005 to that in 2009?
Provide a short and direct response. 1.05. What is the ratio of the Rating (1=low 6=high) of Middle East & North Africa (developing only) in 2005 to that in 2009?
Offer a very short reply. 1.09. What is the ratio of the Rating (1=low 6=high) of Nigeria in 2005 to that in 2009?
Ensure brevity in your answer.  0.89. What is the ratio of the Rating (1=low 6=high) of Latin America(all income levels) in 2005 to that in 2010?
Provide a short and direct response. 1.02. What is the ratio of the Rating (1=low 6=high) in Latin America(all income levels) in 2005 to that in 2011?
Your response must be concise. 1.03. What is the ratio of the Rating (1=low 6=high) of Nigeria in 2005 to that in 2011?
Ensure brevity in your answer.  1. What is the ratio of the Rating (1=low 6=high) of Tajikistan in 2005 to that in 2011?
Provide a short and direct response. 1. What is the ratio of the Rating (1=low 6=high) of Latin America(all income levels) in 2005 to that in 2012?
Offer a very short reply. 1.06. What is the ratio of the Rating (1=low 6=high) of Middle East & North Africa (developing only) in 2005 to that in 2012?
Your answer should be compact. 1. What is the ratio of the Rating (1=low 6=high) of Latin America(all income levels) in 2006 to that in 2007?
Your answer should be compact. 1.03. What is the ratio of the Rating (1=low 6=high) in Middle East & North Africa (developing only) in 2006 to that in 2007?
Keep it short and to the point. 1. What is the ratio of the Rating (1=low 6=high) of Nigeria in 2006 to that in 2007?
Provide a succinct answer. 0.89. What is the ratio of the Rating (1=low 6=high) of Tajikistan in 2006 to that in 2007?
Your answer should be compact. 1. What is the ratio of the Rating (1=low 6=high) of Latin America(all income levels) in 2006 to that in 2008?
Give a very brief answer. 1.03. What is the ratio of the Rating (1=low 6=high) of Middle East & North Africa (developing only) in 2006 to that in 2008?
Offer a terse response. 0.92. What is the ratio of the Rating (1=low 6=high) in Latin America(all income levels) in 2006 to that in 2009?
Ensure brevity in your answer.  1.05. What is the ratio of the Rating (1=low 6=high) in Middle East & North Africa (developing only) in 2006 to that in 2009?
Keep it short and to the point. 1. What is the ratio of the Rating (1=low 6=high) of Latin America(all income levels) in 2006 to that in 2010?
Your answer should be compact. 1.02. What is the ratio of the Rating (1=low 6=high) of Tajikistan in 2006 to that in 2010?
Your answer should be very brief. 1.14. What is the ratio of the Rating (1=low 6=high) of Latin America(all income levels) in 2006 to that in 2011?
Offer a very short reply. 1.03. What is the ratio of the Rating (1=low 6=high) in Tajikistan in 2006 to that in 2011?
Keep it short and to the point. 1. What is the ratio of the Rating (1=low 6=high) in Latin America(all income levels) in 2006 to that in 2012?
Provide a succinct answer. 1.06. What is the ratio of the Rating (1=low 6=high) of Nigeria in 2006 to that in 2012?
Your response must be concise. 0.89. What is the ratio of the Rating (1=low 6=high) of Middle East & North Africa (developing only) in 2007 to that in 2008?
Offer a terse response. 0.92. What is the ratio of the Rating (1=low 6=high) of Tajikistan in 2007 to that in 2008?
Offer a terse response. 1.14. What is the ratio of the Rating (1=low 6=high) of Latin America(all income levels) in 2007 to that in 2009?
Keep it short and to the point. 1.02. What is the ratio of the Rating (1=low 6=high) in Nigeria in 2007 to that in 2009?
Give a very brief answer. 1. What is the ratio of the Rating (1=low 6=high) in Middle East & North Africa (developing only) in 2007 to that in 2010?
Your answer should be very brief. 0.92. What is the ratio of the Rating (1=low 6=high) in Nigeria in 2007 to that in 2010?
Give a very brief answer. 1.12. What is the ratio of the Rating (1=low 6=high) in Nigeria in 2007 to that in 2011?
Ensure brevity in your answer.  1.12. What is the ratio of the Rating (1=low 6=high) in Latin America(all income levels) in 2007 to that in 2012?
Your response must be concise. 1.03. What is the ratio of the Rating (1=low 6=high) of Tajikistan in 2007 to that in 2012?
Your answer should be very brief. 1. What is the ratio of the Rating (1=low 6=high) in Latin America(all income levels) in 2008 to that in 2009?
Provide a succinct answer. 1.02. What is the ratio of the Rating (1=low 6=high) in Middle East & North Africa (developing only) in 2008 to that in 2009?
Make the answer very short. 1.09. What is the ratio of the Rating (1=low 6=high) of Nigeria in 2008 to that in 2009?
Your answer should be compact. 1. What is the ratio of the Rating (1=low 6=high) of Nigeria in 2008 to that in 2010?
Offer a terse response. 1.12. What is the ratio of the Rating (1=low 6=high) in Middle East & North Africa (developing only) in 2008 to that in 2011?
Make the answer very short. 1.09. What is the ratio of the Rating (1=low 6=high) in Nigeria in 2008 to that in 2011?
Give a very brief answer. 1.12. What is the ratio of the Rating (1=low 6=high) of Latin America(all income levels) in 2008 to that in 2012?
Offer a terse response. 1.03. What is the ratio of the Rating (1=low 6=high) of Middle East & North Africa (developing only) in 2008 to that in 2012?
Provide a short and direct response. 1. What is the ratio of the Rating (1=low 6=high) of Latin America(all income levels) in 2009 to that in 2010?
Keep it short and to the point. 0.97. What is the ratio of the Rating (1=low 6=high) of Tajikistan in 2009 to that in 2010?
Your answer should be very brief. 1. What is the ratio of the Rating (1=low 6=high) of Latin America(all income levels) in 2009 to that in 2011?
Give a very brief answer. 0.98. What is the ratio of the Rating (1=low 6=high) in Nigeria in 2009 to that in 2011?
Keep it short and to the point. 1.12. What is the ratio of the Rating (1=low 6=high) of Latin America(all income levels) in 2009 to that in 2012?
Provide a short and direct response. 1.02. What is the ratio of the Rating (1=low 6=high) in Nigeria in 2009 to that in 2012?
Offer a very short reply. 1. What is the ratio of the Rating (1=low 6=high) of Tajikistan in 2009 to that in 2012?
Offer a terse response. 0.88. What is the ratio of the Rating (1=low 6=high) in Latin America(all income levels) in 2010 to that in 2011?
Provide a short and direct response. 1.02. What is the ratio of the Rating (1=low 6=high) of Middle East & North Africa (developing only) in 2010 to that in 2011?
Provide a short and direct response. 1.09. What is the ratio of the Rating (1=low 6=high) of Latin America(all income levels) in 2010 to that in 2012?
Ensure brevity in your answer.  1.05. What is the ratio of the Rating (1=low 6=high) of Latin America(all income levels) in 2011 to that in 2012?
Ensure brevity in your answer.  1.03. What is the ratio of the Rating (1=low 6=high) in Middle East & North Africa (developing only) in 2011 to that in 2012?
Provide a short and direct response. 0.92. What is the ratio of the Rating (1=low 6=high) of Nigeria in 2011 to that in 2012?
Offer a terse response. 0.89. What is the difference between the highest and the second highest Rating (1=low 6=high) of Tajikistan?
Give a very brief answer. 0. What is the difference between the highest and the lowest Rating (1=low 6=high) in Latin America(all income levels)?
Make the answer very short. 0.22. What is the difference between the highest and the lowest Rating (1=low 6=high) of Nigeria?
Offer a very short reply. 0.5. What is the difference between the highest and the lowest Rating (1=low 6=high) of Tajikistan?
Your answer should be compact. 0.5. 